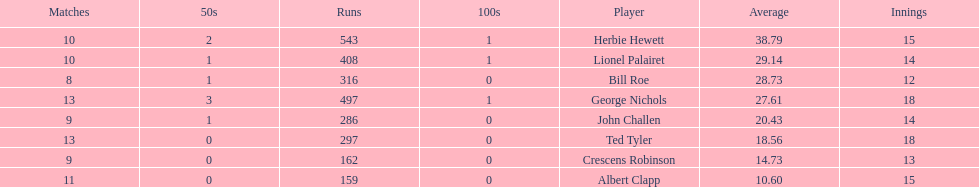How many more runs does john have than albert? 127. 